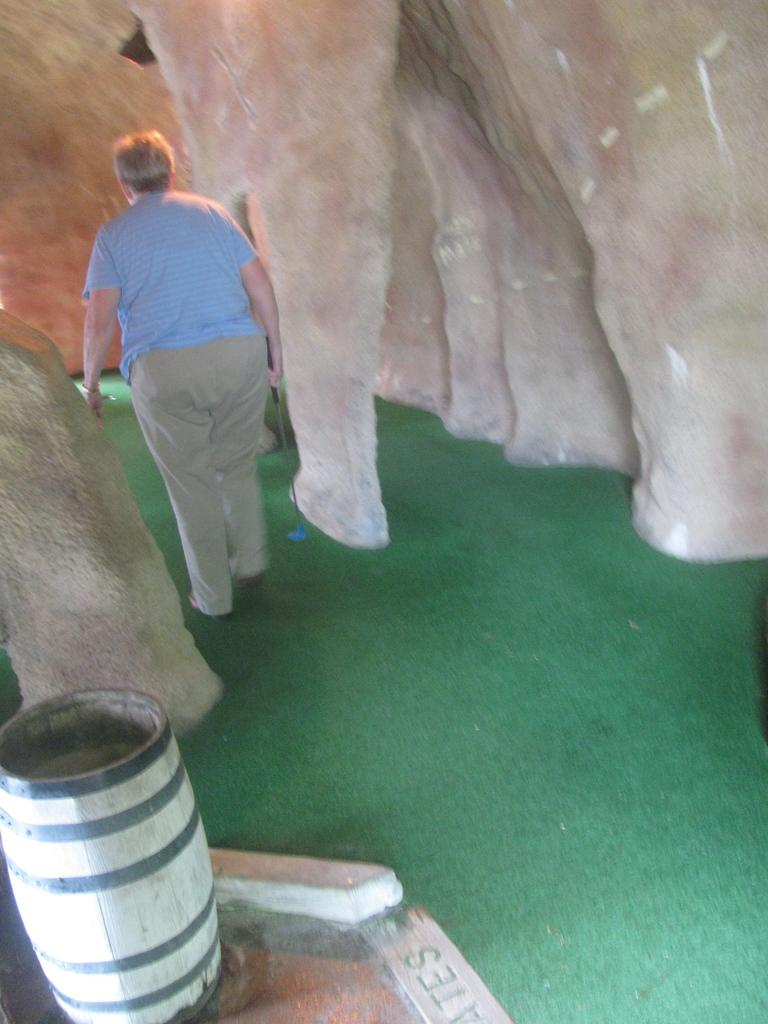Who is present in the image? There is a man in the image. What is the man doing in the image? The man is walking on a green mat. What can be seen in the background of the image? There are pillars in the background of the image. What object is located in the bottom left corner of the image? There is a drum in the bottom left corner of the image. What type of veil is draped over the pillars in the image? There is no veil present in the image; the pillars are visible without any covering. 